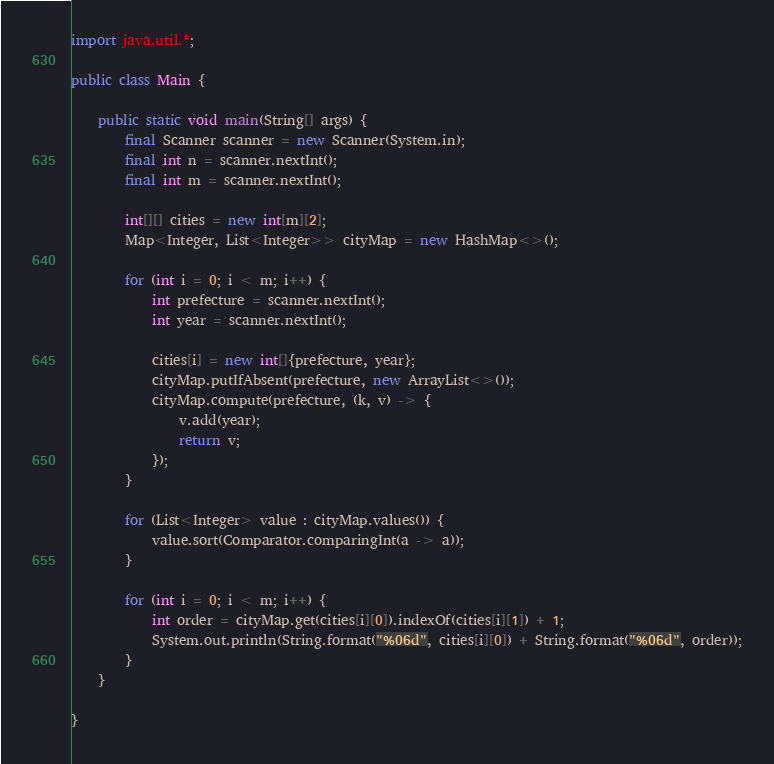Convert code to text. <code><loc_0><loc_0><loc_500><loc_500><_Java_>import java.util.*;

public class Main {

    public static void main(String[] args) {
        final Scanner scanner = new Scanner(System.in);
        final int n = scanner.nextInt();
        final int m = scanner.nextInt();

        int[][] cities = new int[m][2];
        Map<Integer, List<Integer>> cityMap = new HashMap<>();

        for (int i = 0; i < m; i++) {
            int prefecture = scanner.nextInt();
            int year = scanner.nextInt();

            cities[i] = new int[]{prefecture, year};
            cityMap.putIfAbsent(prefecture, new ArrayList<>());
            cityMap.compute(prefecture, (k, v) -> {
                v.add(year);
                return v;
            });
        }

        for (List<Integer> value : cityMap.values()) {
            value.sort(Comparator.comparingInt(a -> a));
        }

        for (int i = 0; i < m; i++) {
            int order = cityMap.get(cities[i][0]).indexOf(cities[i][1]) + 1;
            System.out.println(String.format("%06d", cities[i][0]) + String.format("%06d", order));
        }
    }

}
</code> 